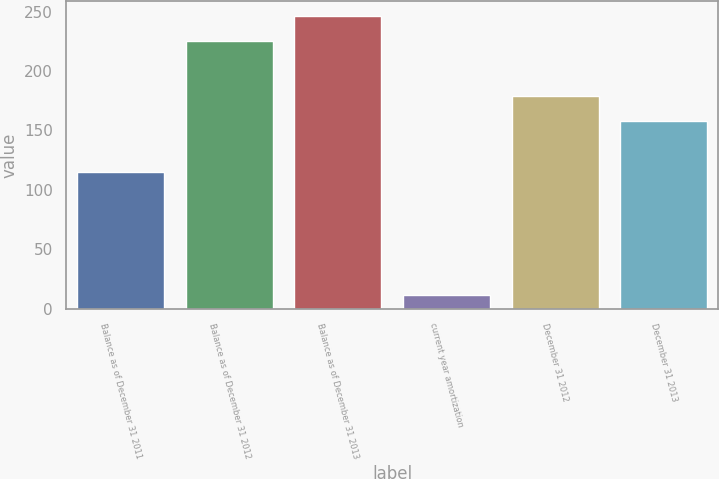Convert chart to OTSL. <chart><loc_0><loc_0><loc_500><loc_500><bar_chart><fcel>Balance as of December 31 2011<fcel>Balance as of December 31 2012<fcel>Balance as of December 31 2013<fcel>current year amortization<fcel>December 31 2012<fcel>December 31 2013<nl><fcel>115<fcel>225<fcel>246.4<fcel>11<fcel>179.4<fcel>158<nl></chart> 